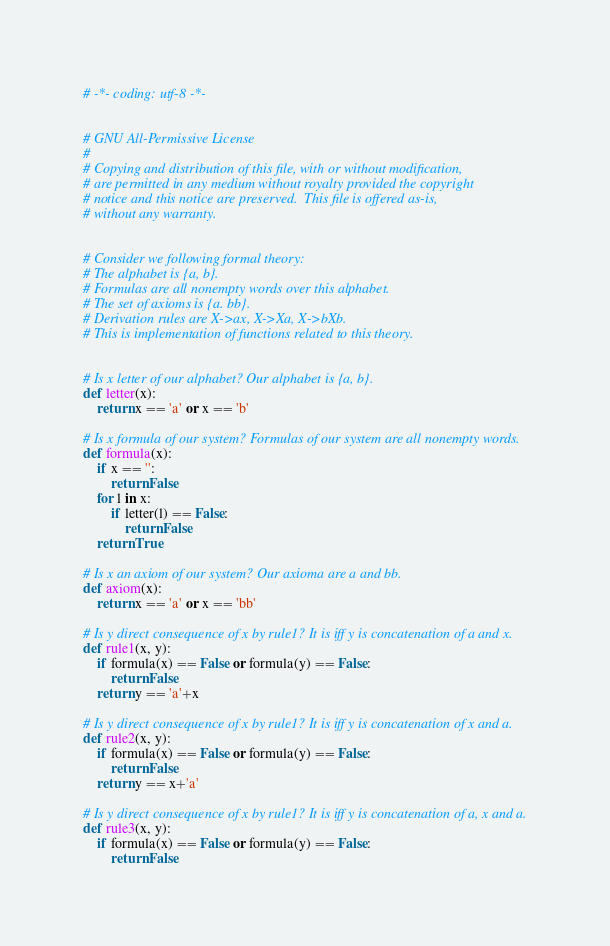Convert code to text. <code><loc_0><loc_0><loc_500><loc_500><_Python_># -*- coding: utf-8 -*-


# GNU All-Permissive License
#
# Copying and distribution of this file, with or without modification,
# are permitted in any medium without royalty provided the copyright
# notice and this notice are preserved.  This file is offered as-is,
# without any warranty.


# Consider we following formal theory:
# The alphabet is {a, b}.
# Formulas are all nonempty words over this alphabet.
# The set of axioms is {a. bb}.
# Derivation rules are X->ax, X->Xa, X->bXb.
# This is implementation of functions related to this theory.


# Is x letter of our alphabet? Our alphabet is {a, b}.
def letter(x):
    return x == 'a' or x == 'b'

# Is x formula of our system? Formulas of our system are all nonempty words.
def formula(x):
    if x == '':
        return False
    for l in x:
        if letter(l) == False:
            return False
    return True

# Is x an axiom of our system? Our axioma are a and bb.
def axiom(x):
    return x == 'a' or x == 'bb'

# Is y direct consequence of x by rule1? It is iff y is concatenation of a and x.
def rule1(x, y):
    if formula(x) == False or formula(y) == False:
        return False
    return y == 'a'+x

# Is y direct consequence of x by rule1? It is iff y is concatenation of x and a.
def rule2(x, y):
    if formula(x) == False or formula(y) == False:
        return False
    return y == x+'a'

# Is y direct consequence of x by rule1? It is iff y is concatenation of a, x and a.
def rule3(x, y):
    if formula(x) == False or formula(y) == False:
        return False</code> 